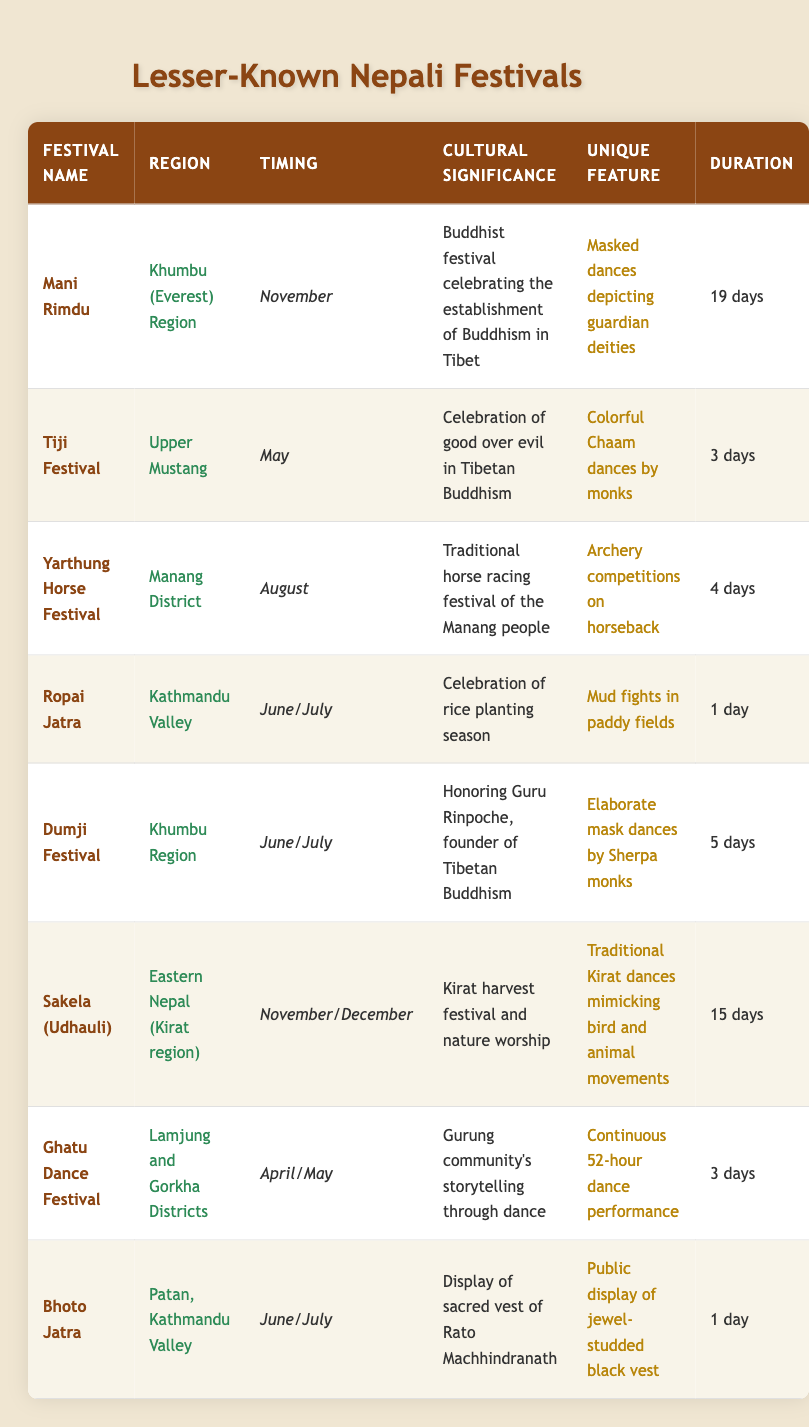What is the duration of the Mani Rimdu festival? The table lists the duration of the Mani Rimdu festival as 19 days.
Answer: 19 days Which festival occurs in the Khumbu Region in June/July? The table shows that the Dumji Festival occurs in the Khumbu Region during June/July.
Answer: Dumji Festival How many days does the Ghatu Dance Festival last? According to the table, the Ghatu Dance Festival lasts for 3 days.
Answer: 3 days Is the Tiji Festival celebrated in the Kathmandu Valley? The table indicates that the Tiji Festival is celebrated in Upper Mustang, not in the Kathmandu Valley. Therefore, the answer is no.
Answer: No What is the unique feature of the Sakela (Udhauli) festival? The table states that the unique feature of the Sakela (Udhauli) festival is traditional Kirat dances that mimic bird and animal movements.
Answer: Traditional Kirat dances mimicking bird and animal movements Which festival has the longest duration, and what is that duration? By comparing the durations listed in the table, the Mani Rimdu festival has the longest duration of 19 days.
Answer: Mani Rimdu, 19 days Are there any festivals that occur in November? Yes, the table mentions that both the Mani Rimdu and Sakela (Udhauli) festivals occur in November.
Answer: Yes What is the average duration of the festivals held in June/July? The festivals in June/July are Ropai Jatra (1 day), Dumji Festival (5 days), and Bhoto Jatra (1 day). The total duration is 1 + 5 + 1 = 7 days, and there are 3 festivals, so the average duration is 7/3 ≈ 2.33 days.
Answer: Approximately 2.33 days Which festival involves archery competitions on horseback? The table specifies that the unique feature of the Yarthung Horse Festival is archery competitions on horseback.
Answer: Yarthung Horse Festival 